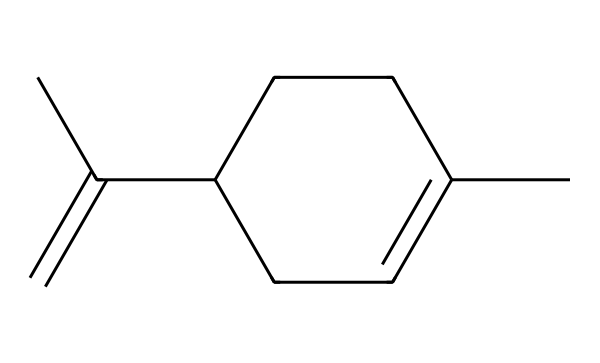How many carbon atoms are in limonene? By looking at the SMILES representation, which shows a total of 10 carbon symbols (C), we can determine the number of carbon atoms present in the structure.
Answer: 10 What is the functional group present in limonene? The structure has a double bond (C=C) which characterizes the compound as an alkene, indicating that the functional group is an alkene group.
Answer: alkene How many double bonds are present in limonene? By reviewing the structure indicated in the SMILES, there is one double bond (C=C) present in the limonene molecule.
Answer: 1 Is limonene a saturated or unsaturated compound? The presence of a double bond in the structure indicates that it is an unsaturated compound; saturated compounds have only single bonds.
Answer: unsaturated What type of scent does limonene primarily provide? Limonene is well-known for its citrus scent, commonly associated with oranges and lemons. Therefore, the primary scent type provided by limonene is citrus.
Answer: citrus What is the primary use of limonene in cleaning products? Limonene serves as a solvent and degreaser, making it effective in cleaning applications, especially in the removal of oily stains or residues.
Answer: solvent Can limonene be classified as a natural or synthetic compound? Limonene is primarily derived from natural sources like citrus fruits, classifying it as a natural compound used in various applications.
Answer: natural 